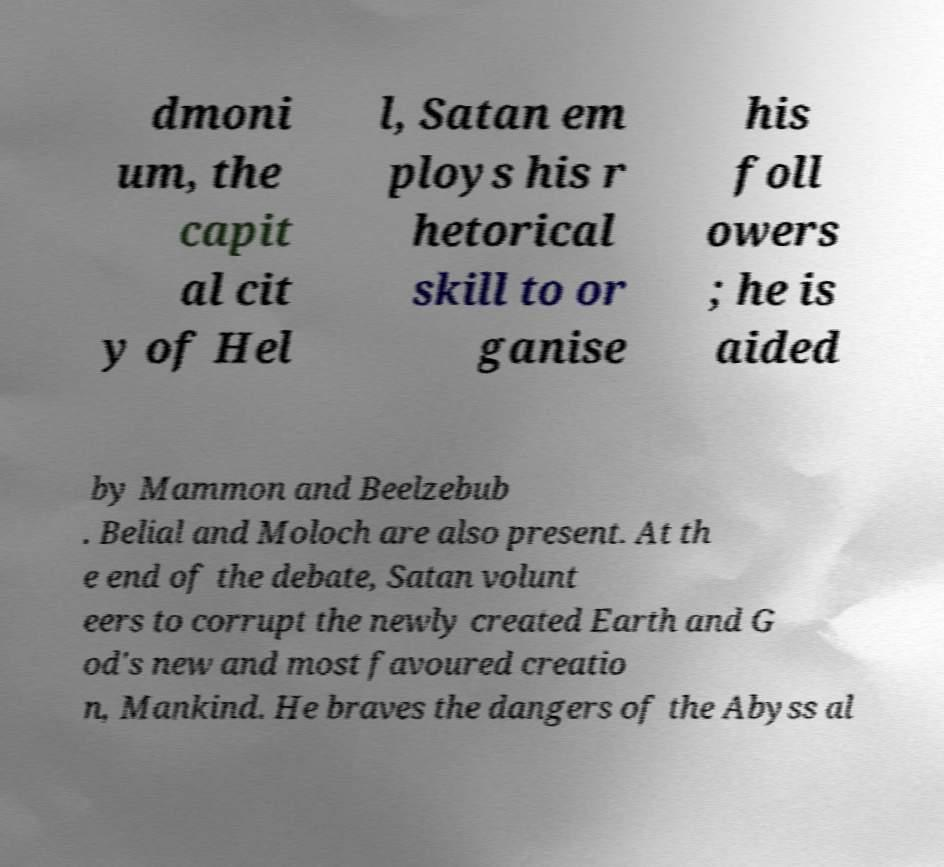Can you accurately transcribe the text from the provided image for me? dmoni um, the capit al cit y of Hel l, Satan em ploys his r hetorical skill to or ganise his foll owers ; he is aided by Mammon and Beelzebub . Belial and Moloch are also present. At th e end of the debate, Satan volunt eers to corrupt the newly created Earth and G od's new and most favoured creatio n, Mankind. He braves the dangers of the Abyss al 